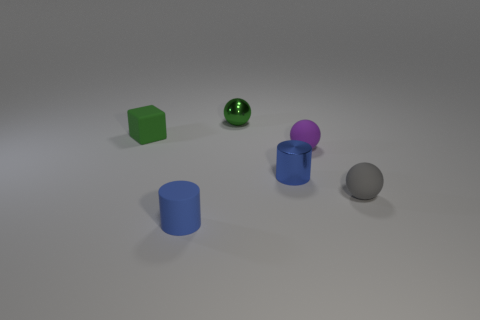What number of objects are small objects in front of the blue metallic cylinder or small shiny cylinders? 3 